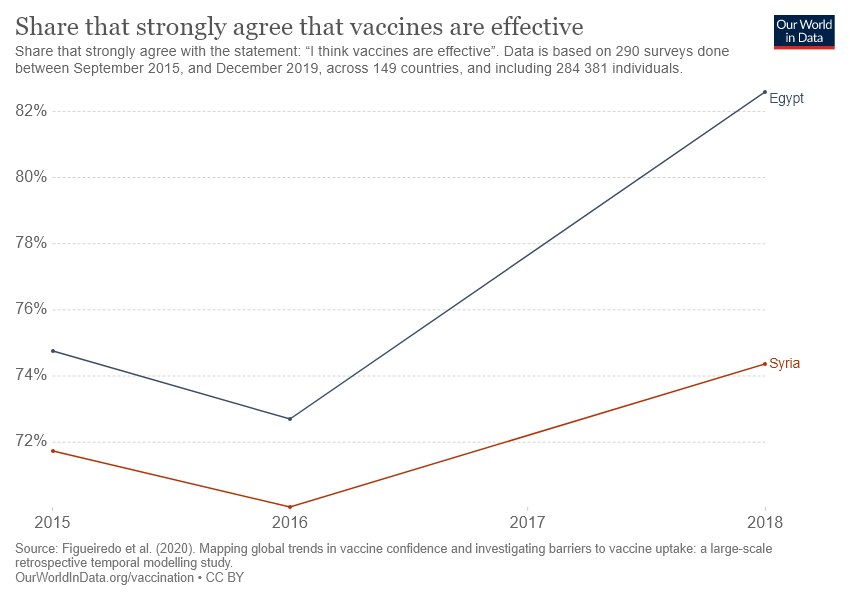Outline some significant characteristics in this image. The red line represents Syria, and it is a significant aspect of the situation we are facing. In 2018, Syria was higher than any other country. 